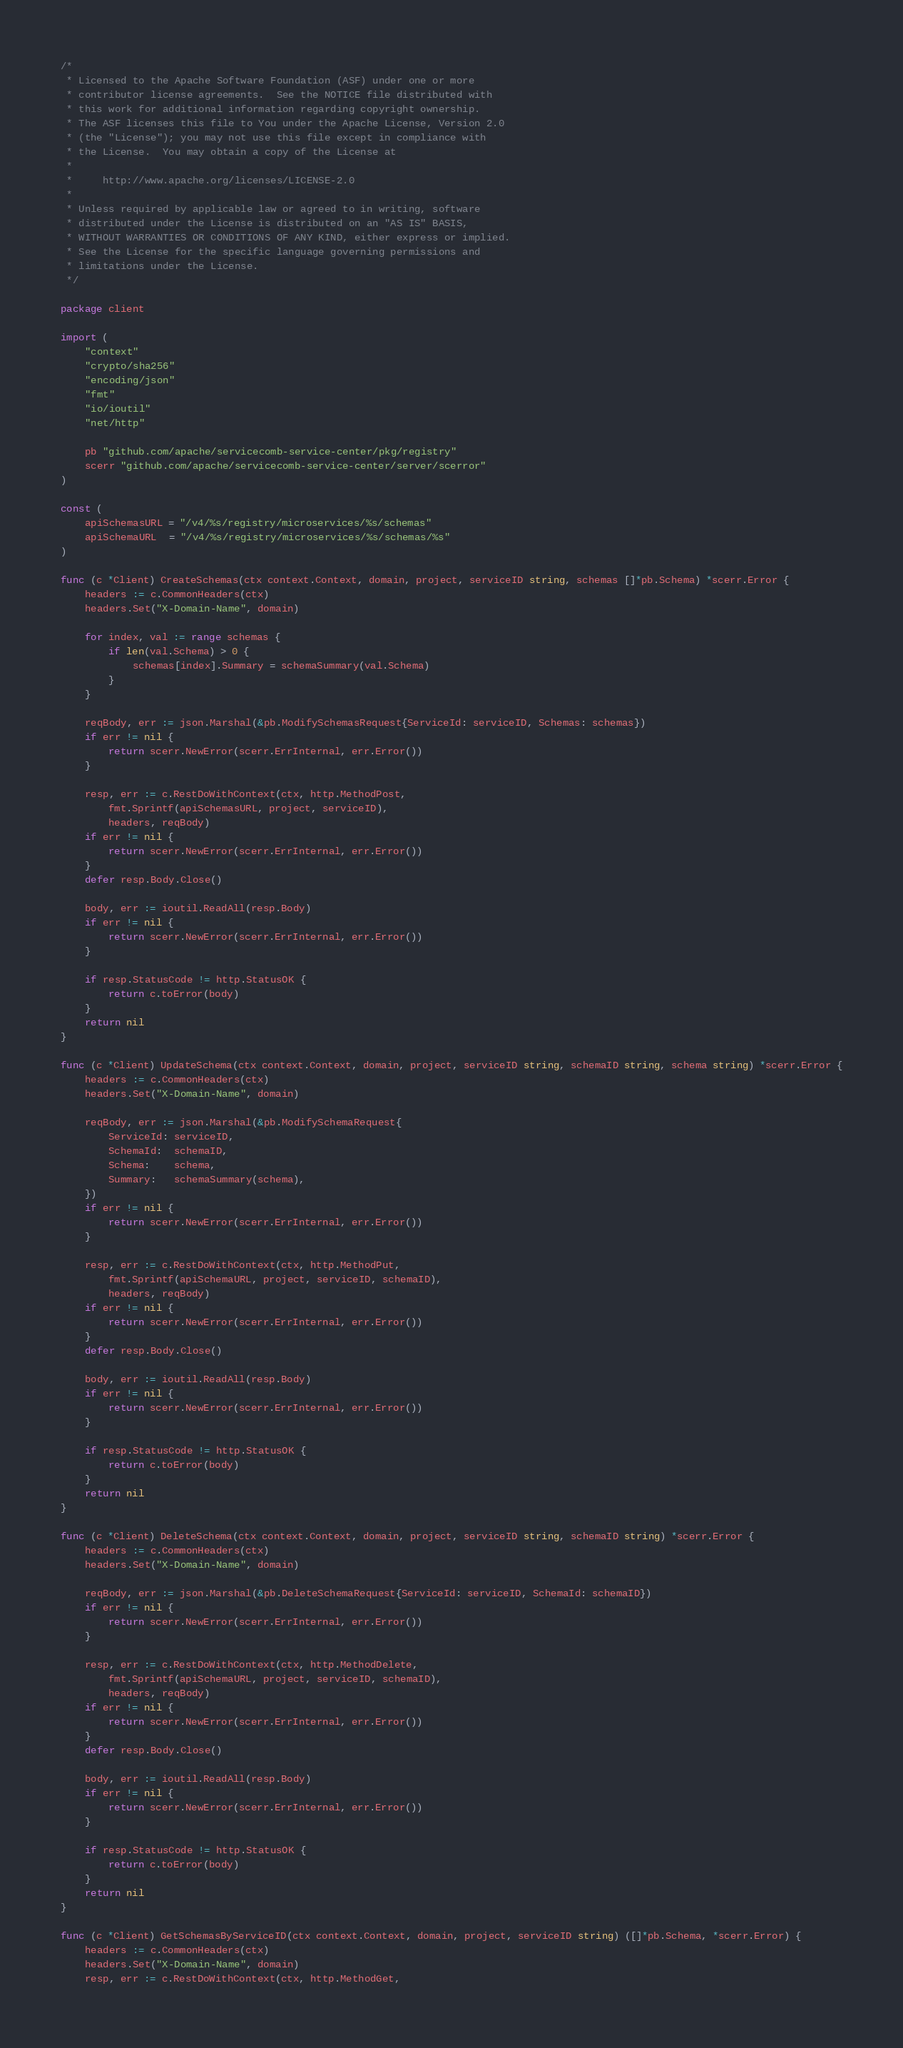Convert code to text. <code><loc_0><loc_0><loc_500><loc_500><_Go_>/*
 * Licensed to the Apache Software Foundation (ASF) under one or more
 * contributor license agreements.  See the NOTICE file distributed with
 * this work for additional information regarding copyright ownership.
 * The ASF licenses this file to You under the Apache License, Version 2.0
 * (the "License"); you may not use this file except in compliance with
 * the License.  You may obtain a copy of the License at
 *
 *     http://www.apache.org/licenses/LICENSE-2.0
 *
 * Unless required by applicable law or agreed to in writing, software
 * distributed under the License is distributed on an "AS IS" BASIS,
 * WITHOUT WARRANTIES OR CONDITIONS OF ANY KIND, either express or implied.
 * See the License for the specific language governing permissions and
 * limitations under the License.
 */

package client

import (
	"context"
	"crypto/sha256"
	"encoding/json"
	"fmt"
	"io/ioutil"
	"net/http"

	pb "github.com/apache/servicecomb-service-center/pkg/registry"
	scerr "github.com/apache/servicecomb-service-center/server/scerror"
)

const (
	apiSchemasURL = "/v4/%s/registry/microservices/%s/schemas"
	apiSchemaURL  = "/v4/%s/registry/microservices/%s/schemas/%s"
)

func (c *Client) CreateSchemas(ctx context.Context, domain, project, serviceID string, schemas []*pb.Schema) *scerr.Error {
	headers := c.CommonHeaders(ctx)
	headers.Set("X-Domain-Name", domain)

	for index, val := range schemas {
		if len(val.Schema) > 0 {
			schemas[index].Summary = schemaSummary(val.Schema)
		}
	}

	reqBody, err := json.Marshal(&pb.ModifySchemasRequest{ServiceId: serviceID, Schemas: schemas})
	if err != nil {
		return scerr.NewError(scerr.ErrInternal, err.Error())
	}

	resp, err := c.RestDoWithContext(ctx, http.MethodPost,
		fmt.Sprintf(apiSchemasURL, project, serviceID),
		headers, reqBody)
	if err != nil {
		return scerr.NewError(scerr.ErrInternal, err.Error())
	}
	defer resp.Body.Close()

	body, err := ioutil.ReadAll(resp.Body)
	if err != nil {
		return scerr.NewError(scerr.ErrInternal, err.Error())
	}

	if resp.StatusCode != http.StatusOK {
		return c.toError(body)
	}
	return nil
}

func (c *Client) UpdateSchema(ctx context.Context, domain, project, serviceID string, schemaID string, schema string) *scerr.Error {
	headers := c.CommonHeaders(ctx)
	headers.Set("X-Domain-Name", domain)

	reqBody, err := json.Marshal(&pb.ModifySchemaRequest{
		ServiceId: serviceID,
		SchemaId:  schemaID,
		Schema:    schema,
		Summary:   schemaSummary(schema),
	})
	if err != nil {
		return scerr.NewError(scerr.ErrInternal, err.Error())
	}

	resp, err := c.RestDoWithContext(ctx, http.MethodPut,
		fmt.Sprintf(apiSchemaURL, project, serviceID, schemaID),
		headers, reqBody)
	if err != nil {
		return scerr.NewError(scerr.ErrInternal, err.Error())
	}
	defer resp.Body.Close()

	body, err := ioutil.ReadAll(resp.Body)
	if err != nil {
		return scerr.NewError(scerr.ErrInternal, err.Error())
	}

	if resp.StatusCode != http.StatusOK {
		return c.toError(body)
	}
	return nil
}

func (c *Client) DeleteSchema(ctx context.Context, domain, project, serviceID string, schemaID string) *scerr.Error {
	headers := c.CommonHeaders(ctx)
	headers.Set("X-Domain-Name", domain)

	reqBody, err := json.Marshal(&pb.DeleteSchemaRequest{ServiceId: serviceID, SchemaId: schemaID})
	if err != nil {
		return scerr.NewError(scerr.ErrInternal, err.Error())
	}

	resp, err := c.RestDoWithContext(ctx, http.MethodDelete,
		fmt.Sprintf(apiSchemaURL, project, serviceID, schemaID),
		headers, reqBody)
	if err != nil {
		return scerr.NewError(scerr.ErrInternal, err.Error())
	}
	defer resp.Body.Close()

	body, err := ioutil.ReadAll(resp.Body)
	if err != nil {
		return scerr.NewError(scerr.ErrInternal, err.Error())
	}

	if resp.StatusCode != http.StatusOK {
		return c.toError(body)
	}
	return nil
}

func (c *Client) GetSchemasByServiceID(ctx context.Context, domain, project, serviceID string) ([]*pb.Schema, *scerr.Error) {
	headers := c.CommonHeaders(ctx)
	headers.Set("X-Domain-Name", domain)
	resp, err := c.RestDoWithContext(ctx, http.MethodGet,</code> 